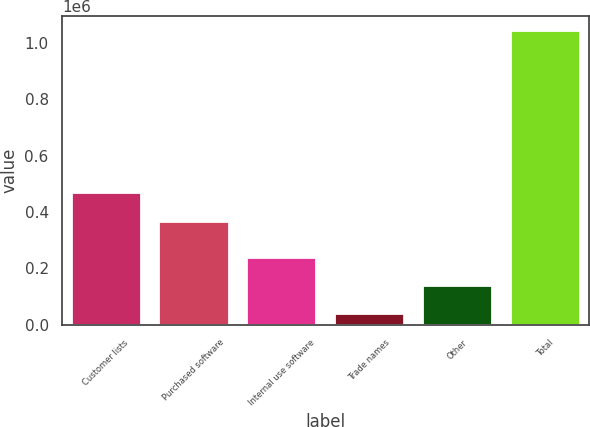Convert chart to OTSL. <chart><loc_0><loc_0><loc_500><loc_500><bar_chart><fcel>Customer lists<fcel>Purchased software<fcel>Internal use software<fcel>Trade names<fcel>Other<fcel>Total<nl><fcel>472697<fcel>369728<fcel>241940<fcel>41224<fcel>141582<fcel>1.0448e+06<nl></chart> 